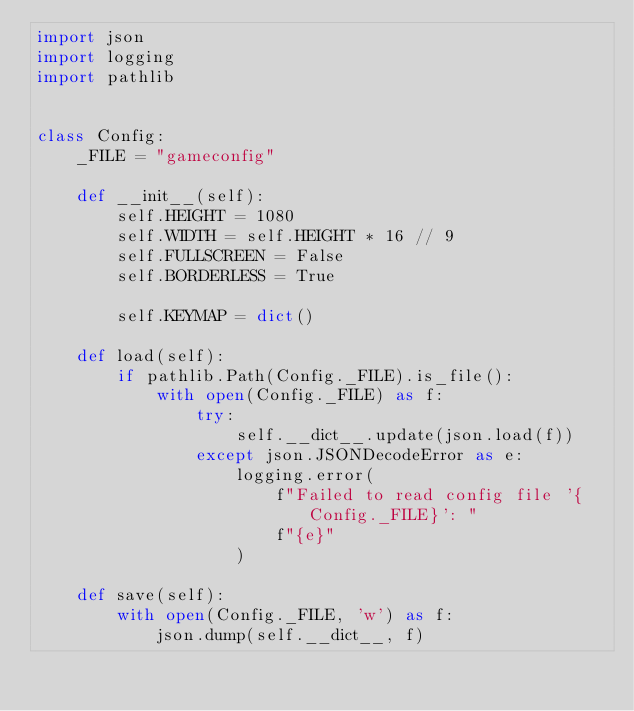<code> <loc_0><loc_0><loc_500><loc_500><_Python_>import json
import logging
import pathlib


class Config:
    _FILE = "gameconfig"

    def __init__(self):
        self.HEIGHT = 1080
        self.WIDTH = self.HEIGHT * 16 // 9
        self.FULLSCREEN = False
        self.BORDERLESS = True

        self.KEYMAP = dict()

    def load(self):
        if pathlib.Path(Config._FILE).is_file():
            with open(Config._FILE) as f:
                try:
                    self.__dict__.update(json.load(f))
                except json.JSONDecodeError as e:
                    logging.error(
                        f"Failed to read config file '{Config._FILE}': "
                        f"{e}"
                    )

    def save(self):
        with open(Config._FILE, 'w') as f:
            json.dump(self.__dict__, f)
</code> 